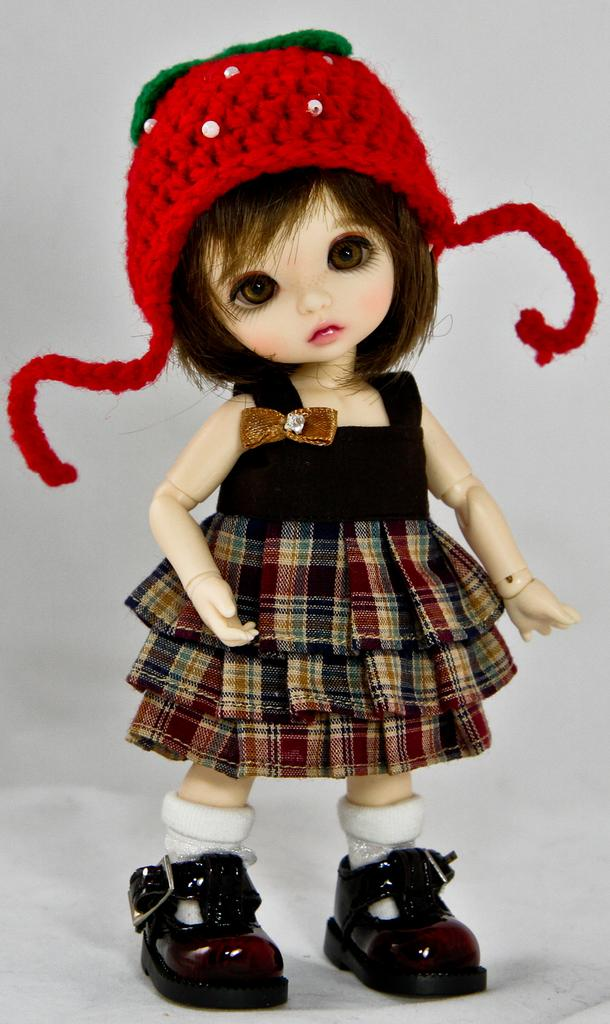What type of toy is in the image? There is a girl toy in the image. What is the girl toy wearing? The girl toy is wearing a dress, a cap, and shoes. What is the color of the background in the image? The background of the image is white. What is the mass of the girl toy in the image? The mass of the girl toy cannot be determined from the image alone. --- 